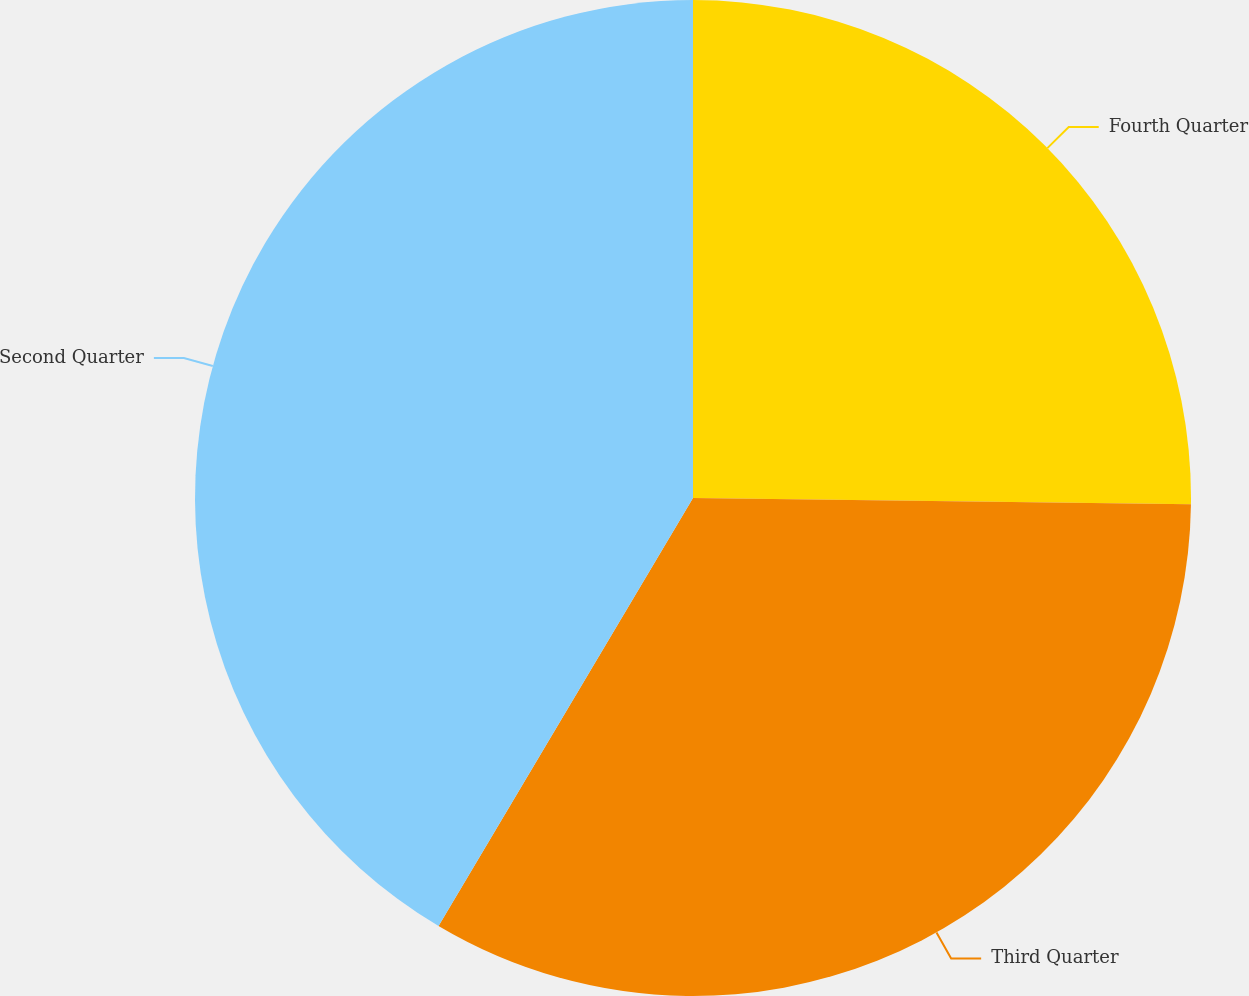Convert chart to OTSL. <chart><loc_0><loc_0><loc_500><loc_500><pie_chart><fcel>Fourth Quarter<fcel>Third Quarter<fcel>Second Quarter<nl><fcel>25.2%<fcel>33.33%<fcel>41.46%<nl></chart> 